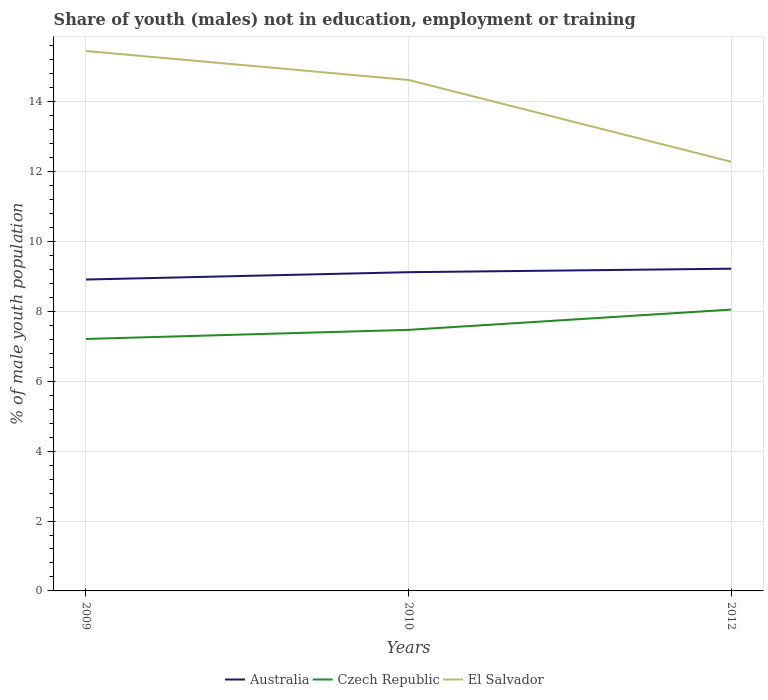How many different coloured lines are there?
Provide a short and direct response. 3. Does the line corresponding to Australia intersect with the line corresponding to Czech Republic?
Ensure brevity in your answer.  No. Across all years, what is the maximum percentage of unemployed males population in in Czech Republic?
Keep it short and to the point. 7.21. What is the total percentage of unemployed males population in in El Salvador in the graph?
Keep it short and to the point. 2.34. What is the difference between the highest and the second highest percentage of unemployed males population in in Czech Republic?
Provide a succinct answer. 0.84. Is the percentage of unemployed males population in in El Salvador strictly greater than the percentage of unemployed males population in in Australia over the years?
Give a very brief answer. No. How many lines are there?
Provide a short and direct response. 3. How many years are there in the graph?
Keep it short and to the point. 3. Are the values on the major ticks of Y-axis written in scientific E-notation?
Offer a terse response. No. How many legend labels are there?
Provide a short and direct response. 3. How are the legend labels stacked?
Ensure brevity in your answer.  Horizontal. What is the title of the graph?
Your answer should be compact. Share of youth (males) not in education, employment or training. What is the label or title of the Y-axis?
Offer a terse response. % of male youth population. What is the % of male youth population of Australia in 2009?
Give a very brief answer. 8.91. What is the % of male youth population of Czech Republic in 2009?
Offer a very short reply. 7.21. What is the % of male youth population of El Salvador in 2009?
Your answer should be very brief. 15.45. What is the % of male youth population of Australia in 2010?
Your answer should be very brief. 9.12. What is the % of male youth population in Czech Republic in 2010?
Give a very brief answer. 7.47. What is the % of male youth population in El Salvador in 2010?
Your answer should be very brief. 14.62. What is the % of male youth population in Australia in 2012?
Give a very brief answer. 9.22. What is the % of male youth population of Czech Republic in 2012?
Your answer should be very brief. 8.05. What is the % of male youth population in El Salvador in 2012?
Ensure brevity in your answer.  12.28. Across all years, what is the maximum % of male youth population of Australia?
Give a very brief answer. 9.22. Across all years, what is the maximum % of male youth population in Czech Republic?
Your answer should be very brief. 8.05. Across all years, what is the maximum % of male youth population of El Salvador?
Make the answer very short. 15.45. Across all years, what is the minimum % of male youth population of Australia?
Keep it short and to the point. 8.91. Across all years, what is the minimum % of male youth population in Czech Republic?
Provide a short and direct response. 7.21. Across all years, what is the minimum % of male youth population in El Salvador?
Provide a short and direct response. 12.28. What is the total % of male youth population in Australia in the graph?
Make the answer very short. 27.25. What is the total % of male youth population in Czech Republic in the graph?
Provide a succinct answer. 22.73. What is the total % of male youth population in El Salvador in the graph?
Provide a succinct answer. 42.35. What is the difference between the % of male youth population of Australia in 2009 and that in 2010?
Give a very brief answer. -0.21. What is the difference between the % of male youth population of Czech Republic in 2009 and that in 2010?
Offer a terse response. -0.26. What is the difference between the % of male youth population of El Salvador in 2009 and that in 2010?
Provide a succinct answer. 0.83. What is the difference between the % of male youth population of Australia in 2009 and that in 2012?
Offer a terse response. -0.31. What is the difference between the % of male youth population of Czech Republic in 2009 and that in 2012?
Offer a terse response. -0.84. What is the difference between the % of male youth population of El Salvador in 2009 and that in 2012?
Offer a terse response. 3.17. What is the difference between the % of male youth population in Czech Republic in 2010 and that in 2012?
Make the answer very short. -0.58. What is the difference between the % of male youth population in El Salvador in 2010 and that in 2012?
Offer a terse response. 2.34. What is the difference between the % of male youth population of Australia in 2009 and the % of male youth population of Czech Republic in 2010?
Offer a very short reply. 1.44. What is the difference between the % of male youth population of Australia in 2009 and the % of male youth population of El Salvador in 2010?
Provide a succinct answer. -5.71. What is the difference between the % of male youth population in Czech Republic in 2009 and the % of male youth population in El Salvador in 2010?
Provide a succinct answer. -7.41. What is the difference between the % of male youth population in Australia in 2009 and the % of male youth population in Czech Republic in 2012?
Offer a terse response. 0.86. What is the difference between the % of male youth population of Australia in 2009 and the % of male youth population of El Salvador in 2012?
Make the answer very short. -3.37. What is the difference between the % of male youth population of Czech Republic in 2009 and the % of male youth population of El Salvador in 2012?
Give a very brief answer. -5.07. What is the difference between the % of male youth population of Australia in 2010 and the % of male youth population of Czech Republic in 2012?
Offer a terse response. 1.07. What is the difference between the % of male youth population of Australia in 2010 and the % of male youth population of El Salvador in 2012?
Offer a terse response. -3.16. What is the difference between the % of male youth population in Czech Republic in 2010 and the % of male youth population in El Salvador in 2012?
Ensure brevity in your answer.  -4.81. What is the average % of male youth population of Australia per year?
Keep it short and to the point. 9.08. What is the average % of male youth population of Czech Republic per year?
Offer a very short reply. 7.58. What is the average % of male youth population in El Salvador per year?
Offer a terse response. 14.12. In the year 2009, what is the difference between the % of male youth population of Australia and % of male youth population of Czech Republic?
Your answer should be compact. 1.7. In the year 2009, what is the difference between the % of male youth population in Australia and % of male youth population in El Salvador?
Your answer should be very brief. -6.54. In the year 2009, what is the difference between the % of male youth population in Czech Republic and % of male youth population in El Salvador?
Your answer should be very brief. -8.24. In the year 2010, what is the difference between the % of male youth population in Australia and % of male youth population in Czech Republic?
Your response must be concise. 1.65. In the year 2010, what is the difference between the % of male youth population in Australia and % of male youth population in El Salvador?
Make the answer very short. -5.5. In the year 2010, what is the difference between the % of male youth population in Czech Republic and % of male youth population in El Salvador?
Your response must be concise. -7.15. In the year 2012, what is the difference between the % of male youth population in Australia and % of male youth population in Czech Republic?
Your answer should be very brief. 1.17. In the year 2012, what is the difference between the % of male youth population in Australia and % of male youth population in El Salvador?
Your answer should be compact. -3.06. In the year 2012, what is the difference between the % of male youth population of Czech Republic and % of male youth population of El Salvador?
Your answer should be compact. -4.23. What is the ratio of the % of male youth population in Czech Republic in 2009 to that in 2010?
Provide a short and direct response. 0.97. What is the ratio of the % of male youth population in El Salvador in 2009 to that in 2010?
Offer a terse response. 1.06. What is the ratio of the % of male youth population in Australia in 2009 to that in 2012?
Provide a succinct answer. 0.97. What is the ratio of the % of male youth population of Czech Republic in 2009 to that in 2012?
Make the answer very short. 0.9. What is the ratio of the % of male youth population of El Salvador in 2009 to that in 2012?
Ensure brevity in your answer.  1.26. What is the ratio of the % of male youth population in Australia in 2010 to that in 2012?
Provide a succinct answer. 0.99. What is the ratio of the % of male youth population in Czech Republic in 2010 to that in 2012?
Your answer should be compact. 0.93. What is the ratio of the % of male youth population in El Salvador in 2010 to that in 2012?
Offer a very short reply. 1.19. What is the difference between the highest and the second highest % of male youth population of Australia?
Provide a short and direct response. 0.1. What is the difference between the highest and the second highest % of male youth population in Czech Republic?
Offer a very short reply. 0.58. What is the difference between the highest and the second highest % of male youth population of El Salvador?
Ensure brevity in your answer.  0.83. What is the difference between the highest and the lowest % of male youth population in Australia?
Your response must be concise. 0.31. What is the difference between the highest and the lowest % of male youth population of Czech Republic?
Make the answer very short. 0.84. What is the difference between the highest and the lowest % of male youth population in El Salvador?
Provide a succinct answer. 3.17. 